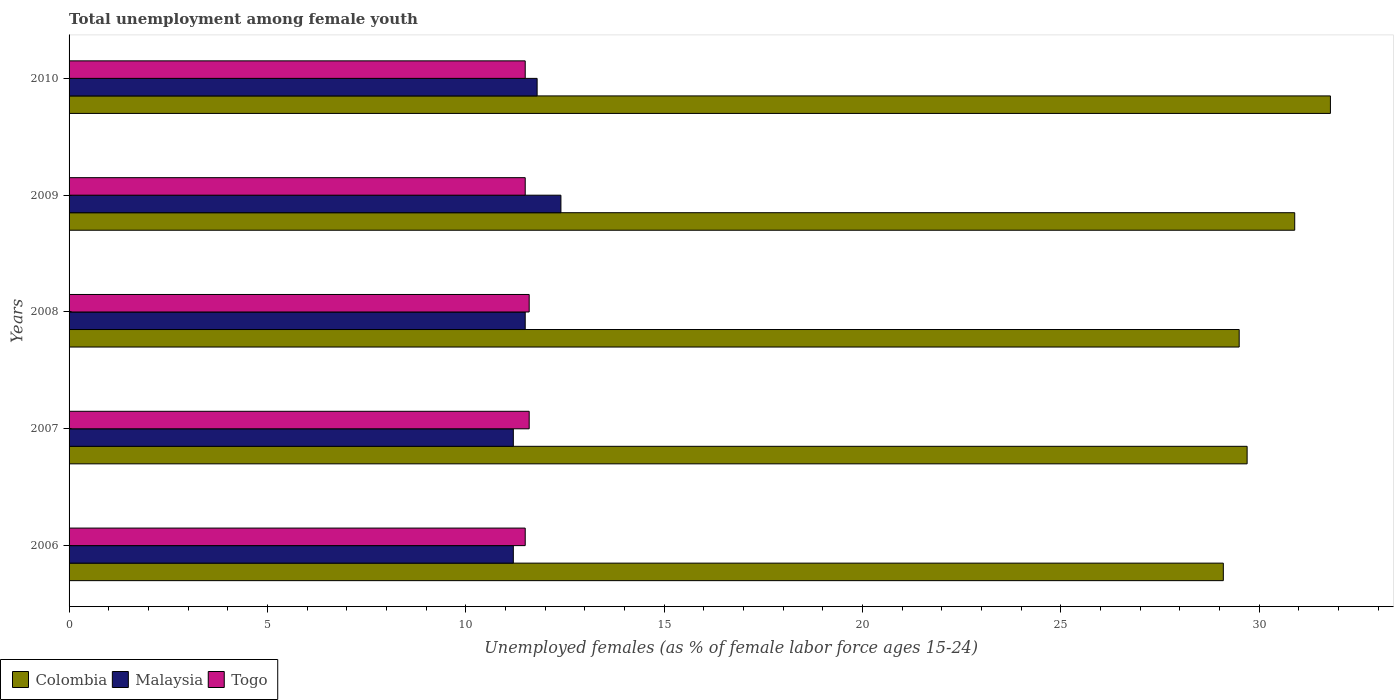How many groups of bars are there?
Your response must be concise. 5. Are the number of bars per tick equal to the number of legend labels?
Offer a very short reply. Yes. Are the number of bars on each tick of the Y-axis equal?
Provide a short and direct response. Yes. How many bars are there on the 4th tick from the bottom?
Your answer should be very brief. 3. What is the percentage of unemployed females in in Togo in 2007?
Your answer should be compact. 11.6. Across all years, what is the maximum percentage of unemployed females in in Togo?
Keep it short and to the point. 11.6. Across all years, what is the minimum percentage of unemployed females in in Malaysia?
Offer a very short reply. 11.2. What is the total percentage of unemployed females in in Malaysia in the graph?
Keep it short and to the point. 58.1. What is the difference between the percentage of unemployed females in in Malaysia in 2007 and that in 2009?
Keep it short and to the point. -1.2. What is the difference between the percentage of unemployed females in in Malaysia in 2006 and the percentage of unemployed females in in Colombia in 2009?
Ensure brevity in your answer.  -19.7. What is the average percentage of unemployed females in in Colombia per year?
Your answer should be compact. 30.2. In the year 2010, what is the difference between the percentage of unemployed females in in Malaysia and percentage of unemployed females in in Togo?
Provide a short and direct response. 0.3. What is the ratio of the percentage of unemployed females in in Colombia in 2007 to that in 2009?
Offer a terse response. 0.96. Is the difference between the percentage of unemployed females in in Malaysia in 2007 and 2010 greater than the difference between the percentage of unemployed females in in Togo in 2007 and 2010?
Keep it short and to the point. No. What is the difference between the highest and the second highest percentage of unemployed females in in Colombia?
Provide a short and direct response. 0.9. What is the difference between the highest and the lowest percentage of unemployed females in in Togo?
Provide a short and direct response. 0.1. In how many years, is the percentage of unemployed females in in Malaysia greater than the average percentage of unemployed females in in Malaysia taken over all years?
Make the answer very short. 2. Is the sum of the percentage of unemployed females in in Togo in 2009 and 2010 greater than the maximum percentage of unemployed females in in Malaysia across all years?
Offer a terse response. Yes. What does the 1st bar from the top in 2008 represents?
Your answer should be compact. Togo. What does the 2nd bar from the bottom in 2006 represents?
Ensure brevity in your answer.  Malaysia. Is it the case that in every year, the sum of the percentage of unemployed females in in Colombia and percentage of unemployed females in in Togo is greater than the percentage of unemployed females in in Malaysia?
Keep it short and to the point. Yes. What is the difference between two consecutive major ticks on the X-axis?
Provide a short and direct response. 5. Are the values on the major ticks of X-axis written in scientific E-notation?
Ensure brevity in your answer.  No. Does the graph contain any zero values?
Keep it short and to the point. No. Where does the legend appear in the graph?
Offer a very short reply. Bottom left. How are the legend labels stacked?
Offer a terse response. Horizontal. What is the title of the graph?
Your answer should be compact. Total unemployment among female youth. Does "Kuwait" appear as one of the legend labels in the graph?
Your answer should be compact. No. What is the label or title of the X-axis?
Offer a terse response. Unemployed females (as % of female labor force ages 15-24). What is the Unemployed females (as % of female labor force ages 15-24) in Colombia in 2006?
Keep it short and to the point. 29.1. What is the Unemployed females (as % of female labor force ages 15-24) of Malaysia in 2006?
Keep it short and to the point. 11.2. What is the Unemployed females (as % of female labor force ages 15-24) in Togo in 2006?
Provide a short and direct response. 11.5. What is the Unemployed females (as % of female labor force ages 15-24) of Colombia in 2007?
Keep it short and to the point. 29.7. What is the Unemployed females (as % of female labor force ages 15-24) in Malaysia in 2007?
Offer a terse response. 11.2. What is the Unemployed females (as % of female labor force ages 15-24) in Togo in 2007?
Provide a succinct answer. 11.6. What is the Unemployed females (as % of female labor force ages 15-24) in Colombia in 2008?
Ensure brevity in your answer.  29.5. What is the Unemployed females (as % of female labor force ages 15-24) of Malaysia in 2008?
Provide a short and direct response. 11.5. What is the Unemployed females (as % of female labor force ages 15-24) in Togo in 2008?
Provide a short and direct response. 11.6. What is the Unemployed females (as % of female labor force ages 15-24) in Colombia in 2009?
Your answer should be compact. 30.9. What is the Unemployed females (as % of female labor force ages 15-24) in Malaysia in 2009?
Offer a very short reply. 12.4. What is the Unemployed females (as % of female labor force ages 15-24) in Colombia in 2010?
Your answer should be compact. 31.8. What is the Unemployed females (as % of female labor force ages 15-24) of Malaysia in 2010?
Offer a terse response. 11.8. Across all years, what is the maximum Unemployed females (as % of female labor force ages 15-24) in Colombia?
Provide a short and direct response. 31.8. Across all years, what is the maximum Unemployed females (as % of female labor force ages 15-24) of Malaysia?
Your answer should be compact. 12.4. Across all years, what is the maximum Unemployed females (as % of female labor force ages 15-24) of Togo?
Keep it short and to the point. 11.6. Across all years, what is the minimum Unemployed females (as % of female labor force ages 15-24) in Colombia?
Give a very brief answer. 29.1. Across all years, what is the minimum Unemployed females (as % of female labor force ages 15-24) of Malaysia?
Offer a terse response. 11.2. What is the total Unemployed females (as % of female labor force ages 15-24) in Colombia in the graph?
Make the answer very short. 151. What is the total Unemployed females (as % of female labor force ages 15-24) in Malaysia in the graph?
Offer a very short reply. 58.1. What is the total Unemployed females (as % of female labor force ages 15-24) in Togo in the graph?
Make the answer very short. 57.7. What is the difference between the Unemployed females (as % of female labor force ages 15-24) of Colombia in 2006 and that in 2007?
Your answer should be compact. -0.6. What is the difference between the Unemployed females (as % of female labor force ages 15-24) of Togo in 2006 and that in 2007?
Your answer should be compact. -0.1. What is the difference between the Unemployed females (as % of female labor force ages 15-24) in Togo in 2006 and that in 2008?
Keep it short and to the point. -0.1. What is the difference between the Unemployed females (as % of female labor force ages 15-24) of Malaysia in 2007 and that in 2010?
Keep it short and to the point. -0.6. What is the difference between the Unemployed females (as % of female labor force ages 15-24) in Colombia in 2008 and that in 2009?
Offer a terse response. -1.4. What is the difference between the Unemployed females (as % of female labor force ages 15-24) in Malaysia in 2008 and that in 2009?
Provide a succinct answer. -0.9. What is the difference between the Unemployed females (as % of female labor force ages 15-24) of Togo in 2008 and that in 2009?
Keep it short and to the point. 0.1. What is the difference between the Unemployed females (as % of female labor force ages 15-24) of Colombia in 2008 and that in 2010?
Your answer should be compact. -2.3. What is the difference between the Unemployed females (as % of female labor force ages 15-24) in Malaysia in 2008 and that in 2010?
Offer a terse response. -0.3. What is the difference between the Unemployed females (as % of female labor force ages 15-24) in Colombia in 2009 and that in 2010?
Keep it short and to the point. -0.9. What is the difference between the Unemployed females (as % of female labor force ages 15-24) in Togo in 2009 and that in 2010?
Provide a short and direct response. 0. What is the difference between the Unemployed females (as % of female labor force ages 15-24) in Colombia in 2006 and the Unemployed females (as % of female labor force ages 15-24) in Malaysia in 2007?
Make the answer very short. 17.9. What is the difference between the Unemployed females (as % of female labor force ages 15-24) in Colombia in 2006 and the Unemployed females (as % of female labor force ages 15-24) in Togo in 2007?
Keep it short and to the point. 17.5. What is the difference between the Unemployed females (as % of female labor force ages 15-24) in Colombia in 2006 and the Unemployed females (as % of female labor force ages 15-24) in Malaysia in 2009?
Make the answer very short. 16.7. What is the difference between the Unemployed females (as % of female labor force ages 15-24) of Colombia in 2006 and the Unemployed females (as % of female labor force ages 15-24) of Togo in 2009?
Provide a succinct answer. 17.6. What is the difference between the Unemployed females (as % of female labor force ages 15-24) of Malaysia in 2006 and the Unemployed females (as % of female labor force ages 15-24) of Togo in 2009?
Your answer should be compact. -0.3. What is the difference between the Unemployed females (as % of female labor force ages 15-24) of Colombia in 2006 and the Unemployed females (as % of female labor force ages 15-24) of Togo in 2010?
Make the answer very short. 17.6. What is the difference between the Unemployed females (as % of female labor force ages 15-24) in Malaysia in 2006 and the Unemployed females (as % of female labor force ages 15-24) in Togo in 2010?
Your answer should be compact. -0.3. What is the difference between the Unemployed females (as % of female labor force ages 15-24) in Colombia in 2007 and the Unemployed females (as % of female labor force ages 15-24) in Togo in 2008?
Your answer should be compact. 18.1. What is the difference between the Unemployed females (as % of female labor force ages 15-24) in Malaysia in 2007 and the Unemployed females (as % of female labor force ages 15-24) in Togo in 2008?
Make the answer very short. -0.4. What is the difference between the Unemployed females (as % of female labor force ages 15-24) in Colombia in 2007 and the Unemployed females (as % of female labor force ages 15-24) in Malaysia in 2010?
Keep it short and to the point. 17.9. What is the difference between the Unemployed females (as % of female labor force ages 15-24) of Colombia in 2008 and the Unemployed females (as % of female labor force ages 15-24) of Togo in 2009?
Your answer should be compact. 18. What is the difference between the Unemployed females (as % of female labor force ages 15-24) in Malaysia in 2008 and the Unemployed females (as % of female labor force ages 15-24) in Togo in 2009?
Offer a terse response. 0. What is the difference between the Unemployed females (as % of female labor force ages 15-24) of Colombia in 2008 and the Unemployed females (as % of female labor force ages 15-24) of Malaysia in 2010?
Your answer should be compact. 17.7. What is the difference between the Unemployed females (as % of female labor force ages 15-24) of Malaysia in 2008 and the Unemployed females (as % of female labor force ages 15-24) of Togo in 2010?
Give a very brief answer. 0. What is the difference between the Unemployed females (as % of female labor force ages 15-24) of Colombia in 2009 and the Unemployed females (as % of female labor force ages 15-24) of Malaysia in 2010?
Ensure brevity in your answer.  19.1. What is the difference between the Unemployed females (as % of female labor force ages 15-24) in Colombia in 2009 and the Unemployed females (as % of female labor force ages 15-24) in Togo in 2010?
Offer a terse response. 19.4. What is the average Unemployed females (as % of female labor force ages 15-24) of Colombia per year?
Provide a succinct answer. 30.2. What is the average Unemployed females (as % of female labor force ages 15-24) in Malaysia per year?
Ensure brevity in your answer.  11.62. What is the average Unemployed females (as % of female labor force ages 15-24) in Togo per year?
Make the answer very short. 11.54. In the year 2006, what is the difference between the Unemployed females (as % of female labor force ages 15-24) in Colombia and Unemployed females (as % of female labor force ages 15-24) in Togo?
Ensure brevity in your answer.  17.6. In the year 2007, what is the difference between the Unemployed females (as % of female labor force ages 15-24) of Colombia and Unemployed females (as % of female labor force ages 15-24) of Malaysia?
Offer a terse response. 18.5. In the year 2007, what is the difference between the Unemployed females (as % of female labor force ages 15-24) in Malaysia and Unemployed females (as % of female labor force ages 15-24) in Togo?
Keep it short and to the point. -0.4. In the year 2008, what is the difference between the Unemployed females (as % of female labor force ages 15-24) of Colombia and Unemployed females (as % of female labor force ages 15-24) of Malaysia?
Your response must be concise. 18. In the year 2008, what is the difference between the Unemployed females (as % of female labor force ages 15-24) in Colombia and Unemployed females (as % of female labor force ages 15-24) in Togo?
Make the answer very short. 17.9. In the year 2008, what is the difference between the Unemployed females (as % of female labor force ages 15-24) of Malaysia and Unemployed females (as % of female labor force ages 15-24) of Togo?
Give a very brief answer. -0.1. In the year 2009, what is the difference between the Unemployed females (as % of female labor force ages 15-24) of Malaysia and Unemployed females (as % of female labor force ages 15-24) of Togo?
Your answer should be compact. 0.9. In the year 2010, what is the difference between the Unemployed females (as % of female labor force ages 15-24) of Colombia and Unemployed females (as % of female labor force ages 15-24) of Malaysia?
Your response must be concise. 20. In the year 2010, what is the difference between the Unemployed females (as % of female labor force ages 15-24) in Colombia and Unemployed females (as % of female labor force ages 15-24) in Togo?
Your response must be concise. 20.3. In the year 2010, what is the difference between the Unemployed females (as % of female labor force ages 15-24) of Malaysia and Unemployed females (as % of female labor force ages 15-24) of Togo?
Give a very brief answer. 0.3. What is the ratio of the Unemployed females (as % of female labor force ages 15-24) in Colombia in 2006 to that in 2007?
Give a very brief answer. 0.98. What is the ratio of the Unemployed females (as % of female labor force ages 15-24) of Togo in 2006 to that in 2007?
Provide a succinct answer. 0.99. What is the ratio of the Unemployed females (as % of female labor force ages 15-24) of Colombia in 2006 to that in 2008?
Your answer should be compact. 0.99. What is the ratio of the Unemployed females (as % of female labor force ages 15-24) of Malaysia in 2006 to that in 2008?
Make the answer very short. 0.97. What is the ratio of the Unemployed females (as % of female labor force ages 15-24) of Togo in 2006 to that in 2008?
Your response must be concise. 0.99. What is the ratio of the Unemployed females (as % of female labor force ages 15-24) of Colombia in 2006 to that in 2009?
Offer a very short reply. 0.94. What is the ratio of the Unemployed females (as % of female labor force ages 15-24) in Malaysia in 2006 to that in 2009?
Your answer should be very brief. 0.9. What is the ratio of the Unemployed females (as % of female labor force ages 15-24) in Colombia in 2006 to that in 2010?
Offer a very short reply. 0.92. What is the ratio of the Unemployed females (as % of female labor force ages 15-24) of Malaysia in 2006 to that in 2010?
Offer a very short reply. 0.95. What is the ratio of the Unemployed females (as % of female labor force ages 15-24) of Togo in 2006 to that in 2010?
Make the answer very short. 1. What is the ratio of the Unemployed females (as % of female labor force ages 15-24) of Colombia in 2007 to that in 2008?
Keep it short and to the point. 1.01. What is the ratio of the Unemployed females (as % of female labor force ages 15-24) of Malaysia in 2007 to that in 2008?
Provide a succinct answer. 0.97. What is the ratio of the Unemployed females (as % of female labor force ages 15-24) of Togo in 2007 to that in 2008?
Provide a succinct answer. 1. What is the ratio of the Unemployed females (as % of female labor force ages 15-24) in Colombia in 2007 to that in 2009?
Offer a very short reply. 0.96. What is the ratio of the Unemployed females (as % of female labor force ages 15-24) in Malaysia in 2007 to that in 2009?
Provide a short and direct response. 0.9. What is the ratio of the Unemployed females (as % of female labor force ages 15-24) of Togo in 2007 to that in 2009?
Your answer should be compact. 1.01. What is the ratio of the Unemployed females (as % of female labor force ages 15-24) of Colombia in 2007 to that in 2010?
Ensure brevity in your answer.  0.93. What is the ratio of the Unemployed females (as % of female labor force ages 15-24) in Malaysia in 2007 to that in 2010?
Ensure brevity in your answer.  0.95. What is the ratio of the Unemployed females (as % of female labor force ages 15-24) in Togo in 2007 to that in 2010?
Provide a short and direct response. 1.01. What is the ratio of the Unemployed females (as % of female labor force ages 15-24) of Colombia in 2008 to that in 2009?
Ensure brevity in your answer.  0.95. What is the ratio of the Unemployed females (as % of female labor force ages 15-24) in Malaysia in 2008 to that in 2009?
Your answer should be compact. 0.93. What is the ratio of the Unemployed females (as % of female labor force ages 15-24) of Togo in 2008 to that in 2009?
Provide a short and direct response. 1.01. What is the ratio of the Unemployed females (as % of female labor force ages 15-24) in Colombia in 2008 to that in 2010?
Make the answer very short. 0.93. What is the ratio of the Unemployed females (as % of female labor force ages 15-24) of Malaysia in 2008 to that in 2010?
Provide a short and direct response. 0.97. What is the ratio of the Unemployed females (as % of female labor force ages 15-24) of Togo in 2008 to that in 2010?
Give a very brief answer. 1.01. What is the ratio of the Unemployed females (as % of female labor force ages 15-24) in Colombia in 2009 to that in 2010?
Provide a succinct answer. 0.97. What is the ratio of the Unemployed females (as % of female labor force ages 15-24) of Malaysia in 2009 to that in 2010?
Offer a very short reply. 1.05. What is the difference between the highest and the second highest Unemployed females (as % of female labor force ages 15-24) of Colombia?
Offer a very short reply. 0.9. What is the difference between the highest and the lowest Unemployed females (as % of female labor force ages 15-24) in Colombia?
Provide a succinct answer. 2.7. 